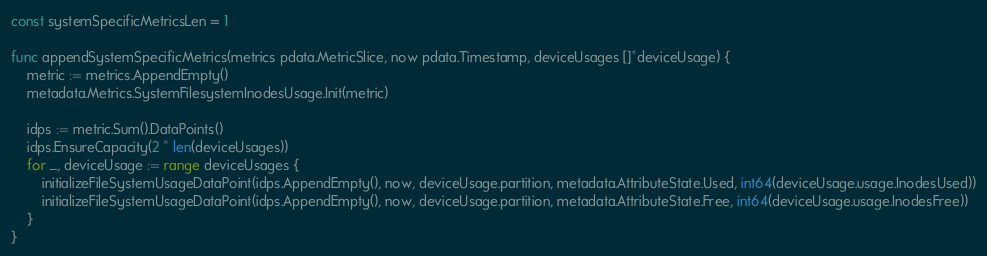<code> <loc_0><loc_0><loc_500><loc_500><_Go_>const systemSpecificMetricsLen = 1

func appendSystemSpecificMetrics(metrics pdata.MetricSlice, now pdata.Timestamp, deviceUsages []*deviceUsage) {
	metric := metrics.AppendEmpty()
	metadata.Metrics.SystemFilesystemInodesUsage.Init(metric)

	idps := metric.Sum().DataPoints()
	idps.EnsureCapacity(2 * len(deviceUsages))
	for _, deviceUsage := range deviceUsages {
		initializeFileSystemUsageDataPoint(idps.AppendEmpty(), now, deviceUsage.partition, metadata.AttributeState.Used, int64(deviceUsage.usage.InodesUsed))
		initializeFileSystemUsageDataPoint(idps.AppendEmpty(), now, deviceUsage.partition, metadata.AttributeState.Free, int64(deviceUsage.usage.InodesFree))
	}
}
</code> 